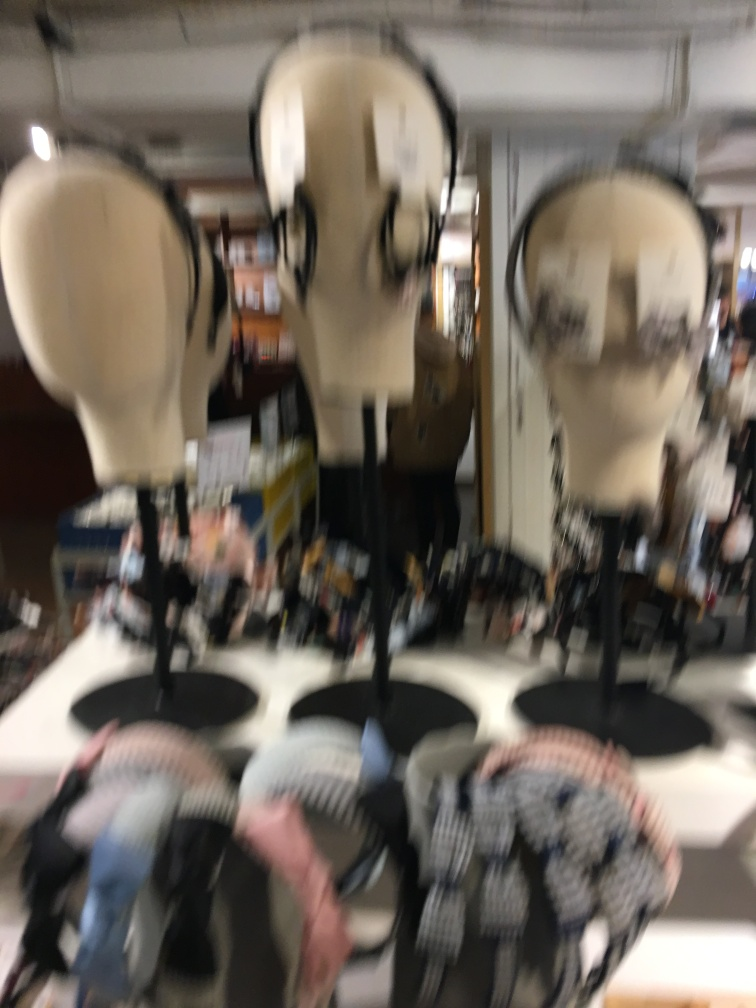Can you describe the items that appear to be in focus in this image? Due to the blur in the image, it's difficult to describe items in focus with precision. From what is discernible, there appear to be several mannequin heads potentially used for displaying headwear or accessories. 